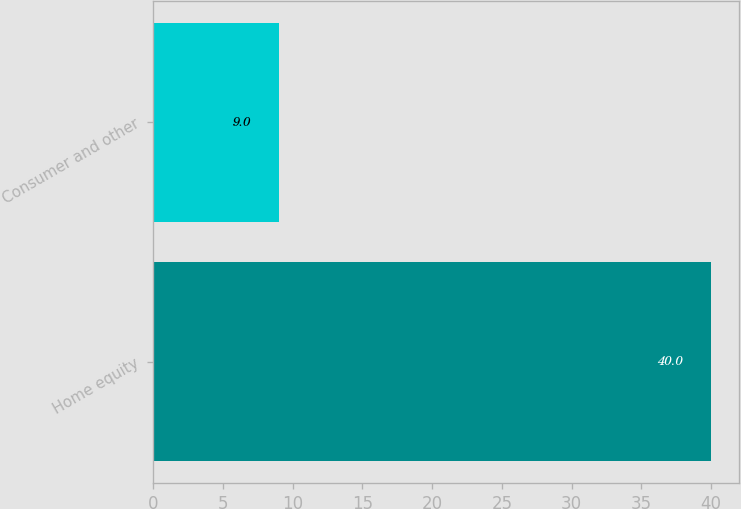<chart> <loc_0><loc_0><loc_500><loc_500><bar_chart><fcel>Home equity<fcel>Consumer and other<nl><fcel>40<fcel>9<nl></chart> 